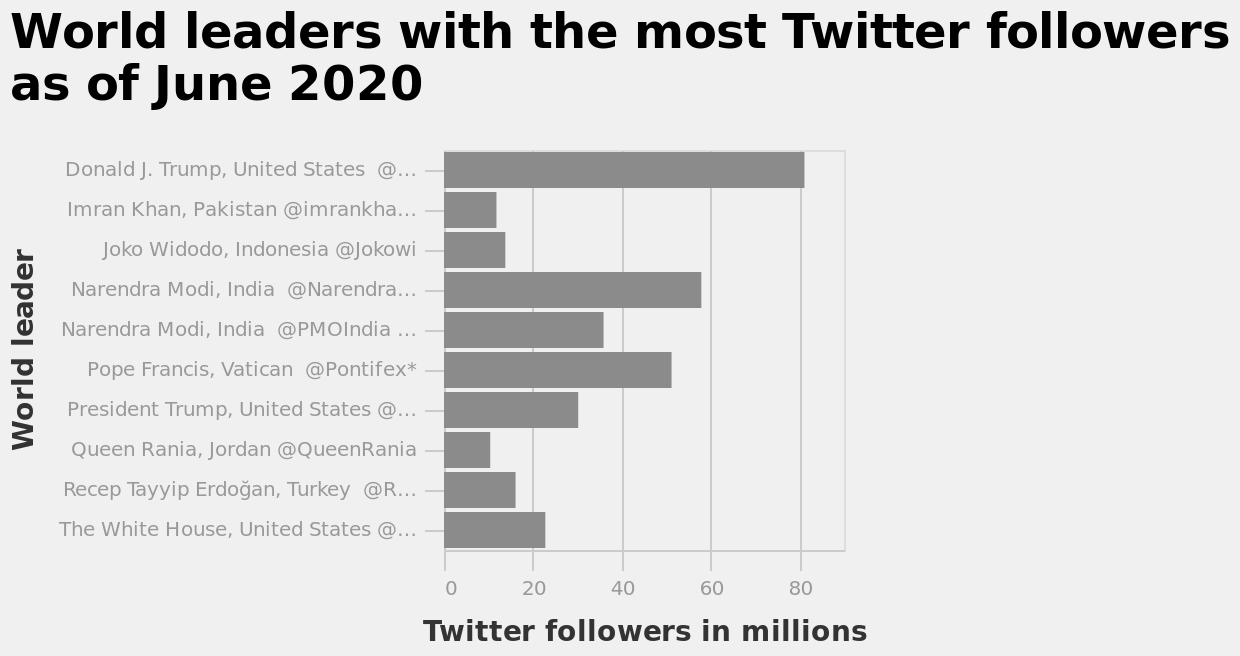<image>
What is plotted on the y-axis of this bar graph? The y-axis of this bar graph represents the world leaders. Offer a thorough analysis of the image. Donald J. Trump has the most Twitter followers with over 80 million followers. Narenda Modi has the second most Twitter followers, with almost 60 million. Pope Francis has the third most followers with approximately 50 million. Queen Rania has the fewest followers, with around 10 million. Imran Khan, Joko Widodo, and Recep Tayyip Erdogan all have a similar number of followers, ranging from around 10 to 20 million. Both Donald J Trump and Narenda Modi both has more followers on their personal Twitter accounts than their official Twitter accounts. What is the timeframe for the data presented in this bar graph? The data presented in this bar graph is as of June 2020. Who has the second most Twitter followers?  Narenda Modi has the second most Twitter followers, with almost 60 million. 